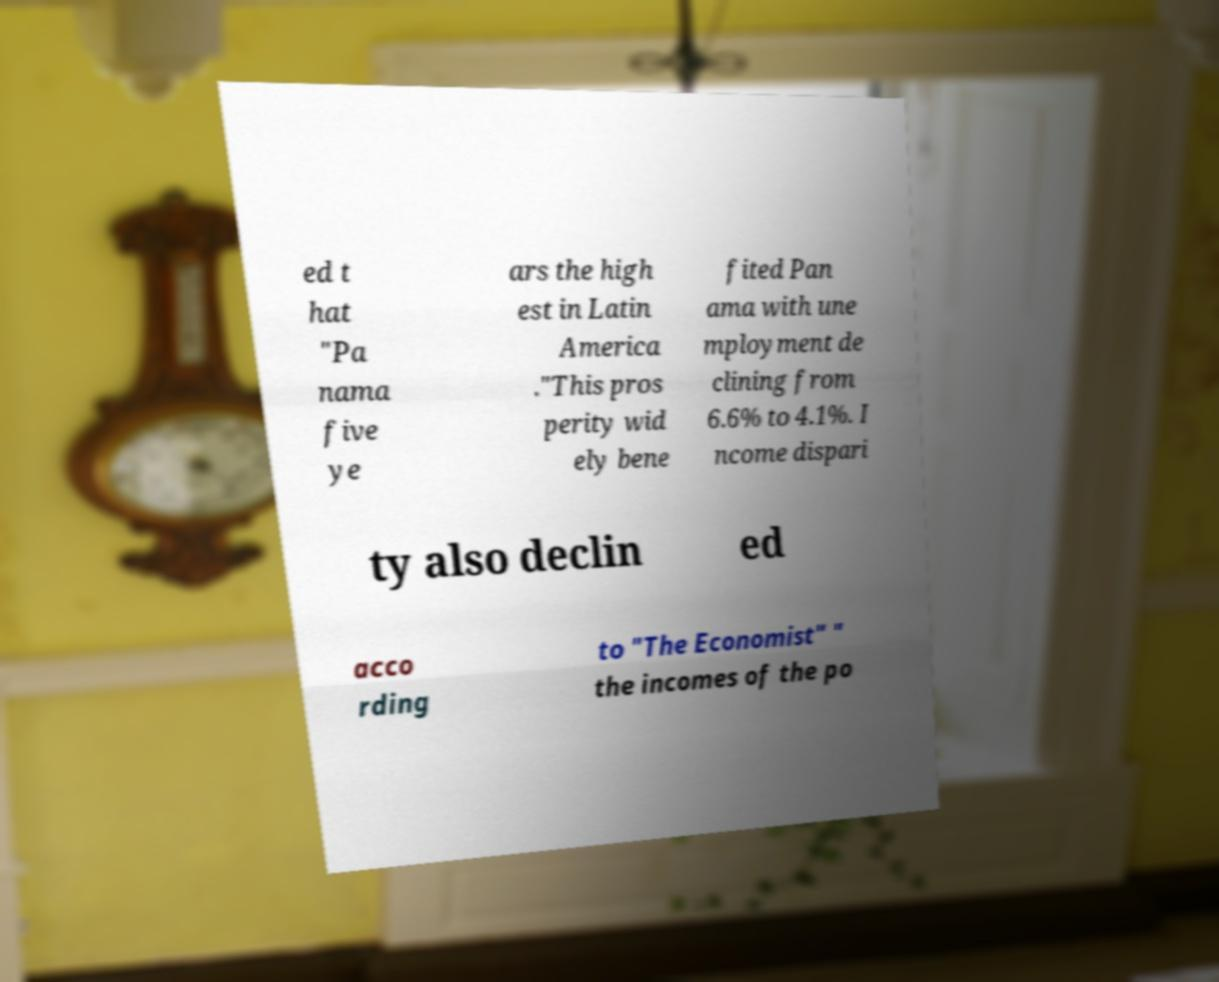For documentation purposes, I need the text within this image transcribed. Could you provide that? ed t hat "Pa nama five ye ars the high est in Latin America ."This pros perity wid ely bene fited Pan ama with une mployment de clining from 6.6% to 4.1%. I ncome dispari ty also declin ed acco rding to "The Economist" " the incomes of the po 